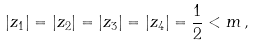<formula> <loc_0><loc_0><loc_500><loc_500>| z _ { 1 } | = | z _ { 2 } | = | z _ { 3 } | = | z _ { 4 } | = { \frac { 1 } { 2 } } < m \, ,</formula> 